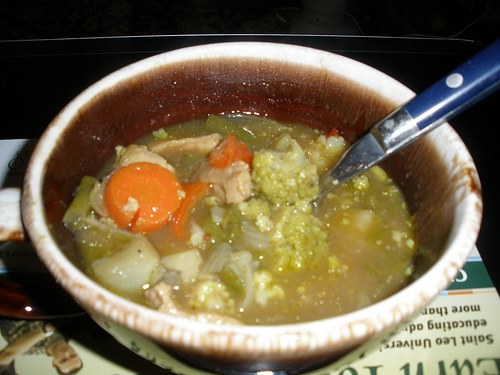What is the vegetable to the left of the veggies in the soup called? The vegetable to the left of the veggies in the soup is a carrot. 